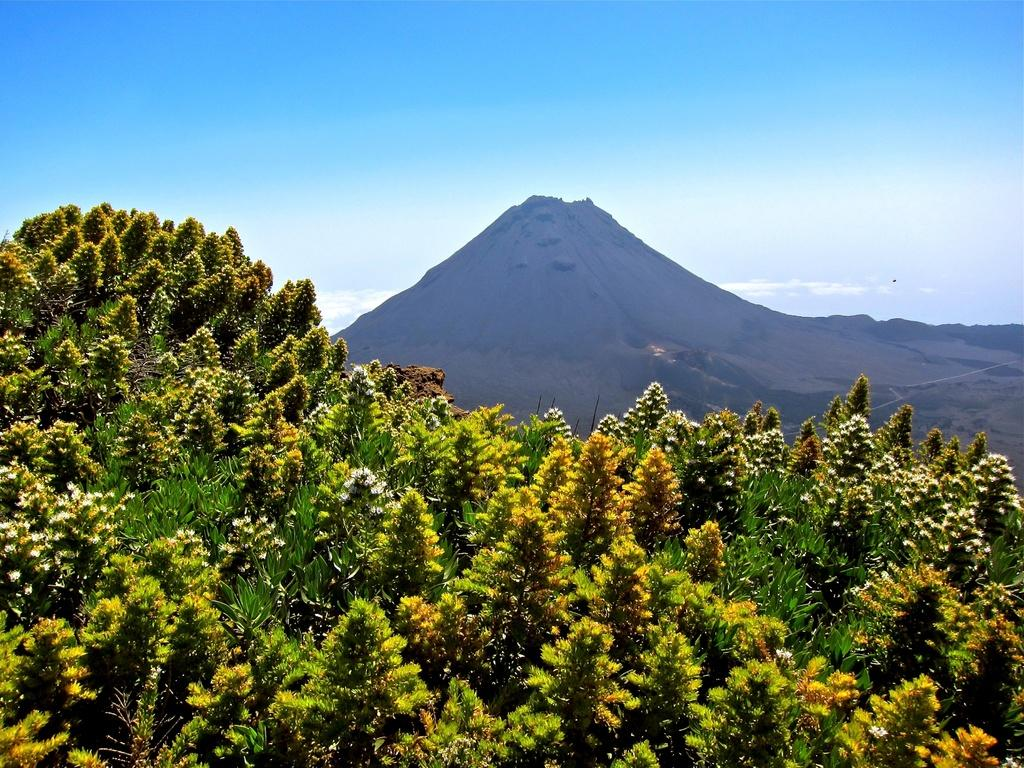What types of living organisms can be seen in the image? Plants and flowers are visible in the image. What natural feature can be seen in the background of the image? There is a mountain in the background of the image. What part of the natural environment is visible in the image? The sky is visible in the background of the image. How many girls are holding cheese in the image? There are no girls or cheese present in the image. 